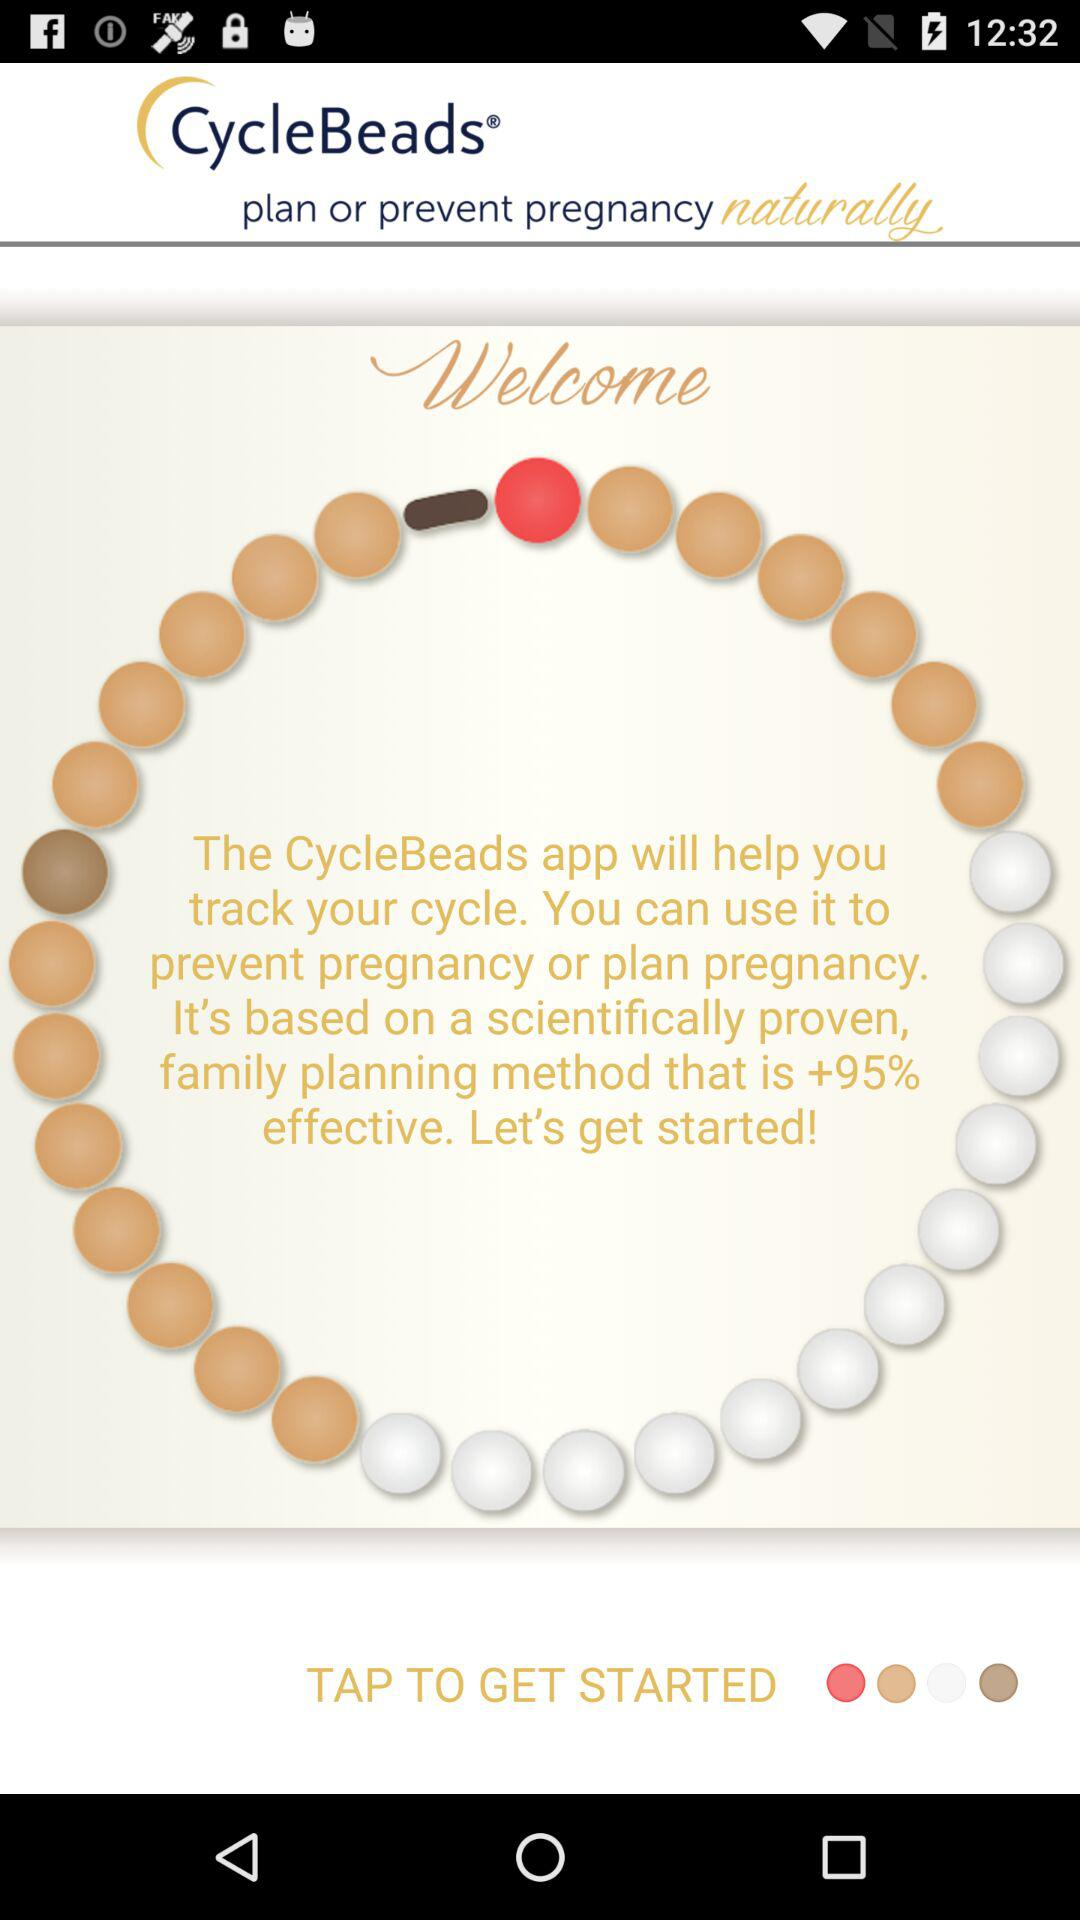What is the name of the application? The application name is "CycleBeads". 